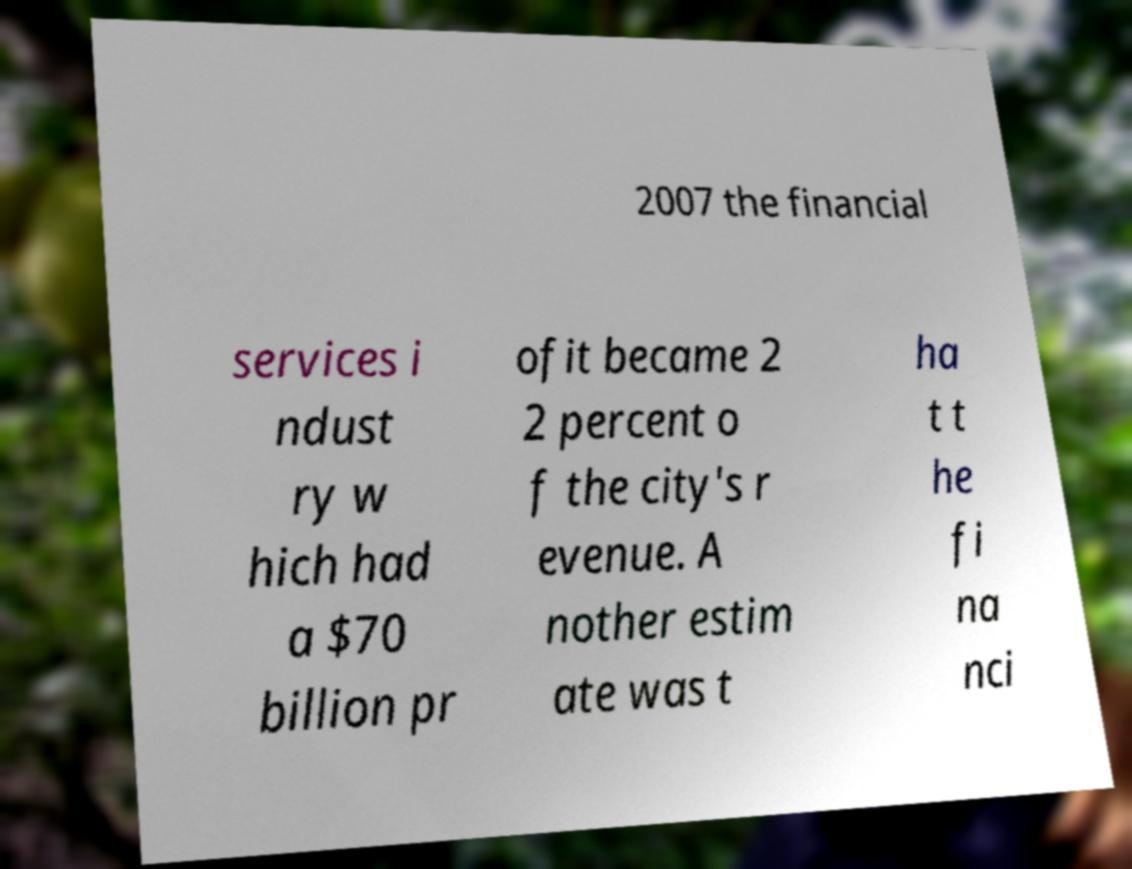There's text embedded in this image that I need extracted. Can you transcribe it verbatim? 2007 the financial services i ndust ry w hich had a $70 billion pr ofit became 2 2 percent o f the city's r evenue. A nother estim ate was t ha t t he fi na nci 